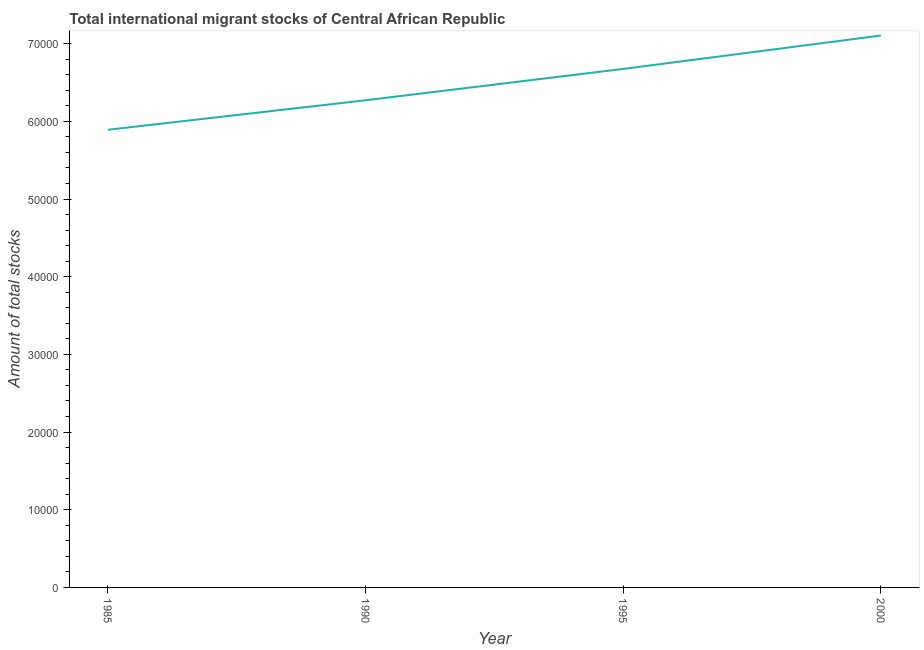What is the total number of international migrant stock in 1990?
Offer a very short reply. 6.27e+04. Across all years, what is the maximum total number of international migrant stock?
Offer a terse response. 7.10e+04. Across all years, what is the minimum total number of international migrant stock?
Provide a succinct answer. 5.89e+04. In which year was the total number of international migrant stock minimum?
Your answer should be very brief. 1985. What is the sum of the total number of international migrant stock?
Offer a very short reply. 2.59e+05. What is the difference between the total number of international migrant stock in 1985 and 1990?
Your answer should be very brief. -3794. What is the average total number of international migrant stock per year?
Give a very brief answer. 6.49e+04. What is the median total number of international migrant stock?
Offer a very short reply. 6.47e+04. In how many years, is the total number of international migrant stock greater than 34000 ?
Provide a short and direct response. 4. Do a majority of the years between 1990 and 2000 (inclusive) have total number of international migrant stock greater than 34000 ?
Provide a succinct answer. Yes. What is the ratio of the total number of international migrant stock in 1985 to that in 1995?
Your answer should be compact. 0.88. Is the total number of international migrant stock in 1985 less than that in 1995?
Ensure brevity in your answer.  Yes. What is the difference between the highest and the second highest total number of international migrant stock?
Ensure brevity in your answer.  4297. What is the difference between the highest and the lowest total number of international migrant stock?
Keep it short and to the point. 1.21e+04. In how many years, is the total number of international migrant stock greater than the average total number of international migrant stock taken over all years?
Make the answer very short. 2. Does the total number of international migrant stock monotonically increase over the years?
Provide a short and direct response. Yes. Does the graph contain any zero values?
Keep it short and to the point. No. What is the title of the graph?
Keep it short and to the point. Total international migrant stocks of Central African Republic. What is the label or title of the Y-axis?
Give a very brief answer. Amount of total stocks. What is the Amount of total stocks in 1985?
Provide a succinct answer. 5.89e+04. What is the Amount of total stocks in 1990?
Make the answer very short. 6.27e+04. What is the Amount of total stocks in 1995?
Provide a succinct answer. 6.68e+04. What is the Amount of total stocks in 2000?
Provide a succinct answer. 7.10e+04. What is the difference between the Amount of total stocks in 1985 and 1990?
Offer a terse response. -3794. What is the difference between the Amount of total stocks in 1985 and 1995?
Ensure brevity in your answer.  -7832. What is the difference between the Amount of total stocks in 1985 and 2000?
Your response must be concise. -1.21e+04. What is the difference between the Amount of total stocks in 1990 and 1995?
Offer a terse response. -4038. What is the difference between the Amount of total stocks in 1990 and 2000?
Your answer should be compact. -8335. What is the difference between the Amount of total stocks in 1995 and 2000?
Make the answer very short. -4297. What is the ratio of the Amount of total stocks in 1985 to that in 1990?
Provide a short and direct response. 0.94. What is the ratio of the Amount of total stocks in 1985 to that in 1995?
Your response must be concise. 0.88. What is the ratio of the Amount of total stocks in 1985 to that in 2000?
Provide a succinct answer. 0.83. What is the ratio of the Amount of total stocks in 1990 to that in 1995?
Your answer should be very brief. 0.94. What is the ratio of the Amount of total stocks in 1990 to that in 2000?
Provide a short and direct response. 0.88. 